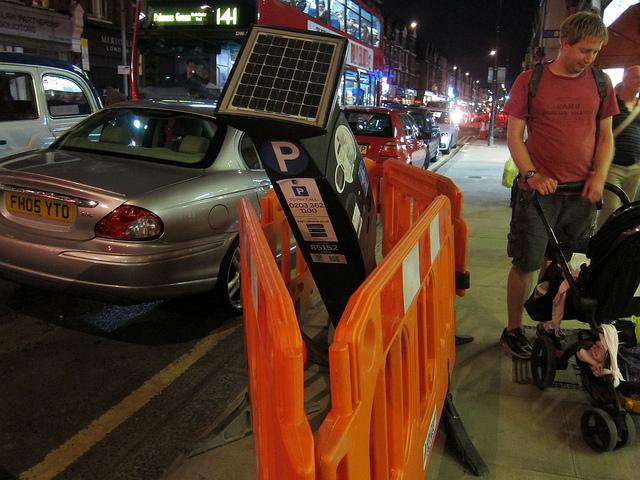Which make of vehicle is parked nearest to the meter? jaguar 